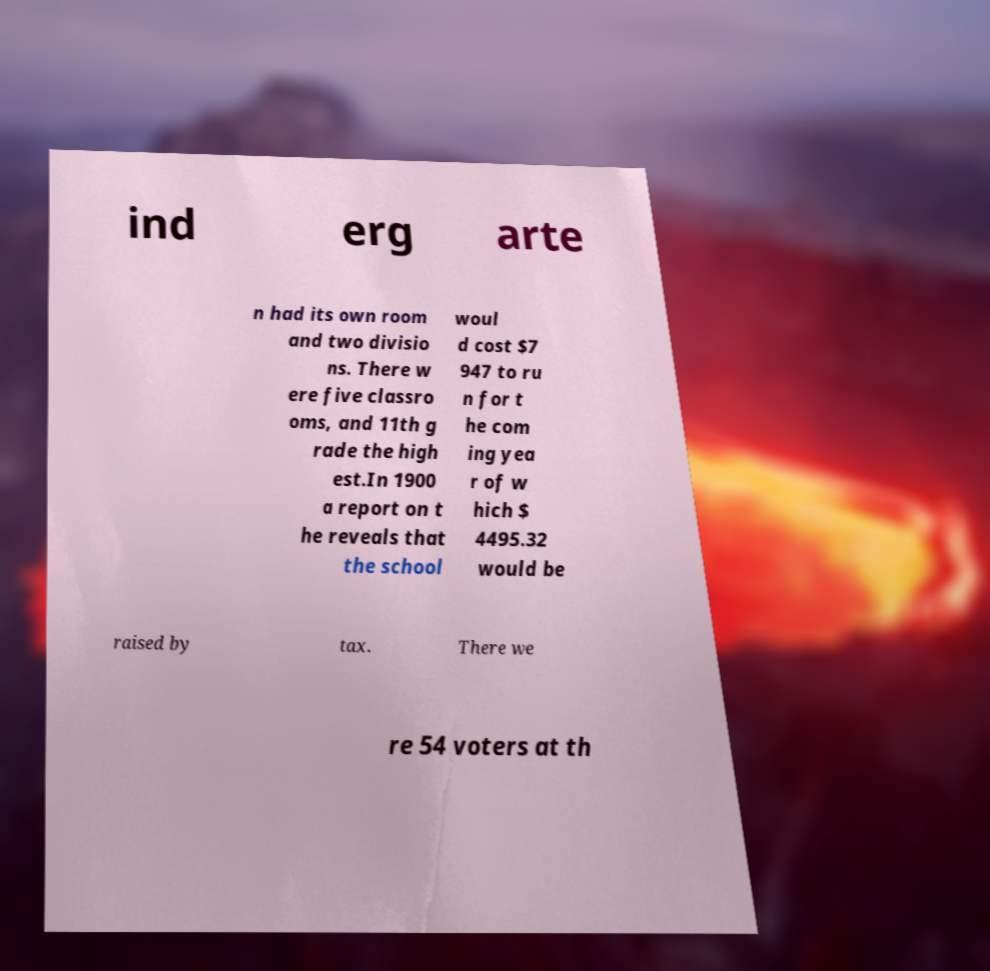Could you assist in decoding the text presented in this image and type it out clearly? ind erg arte n had its own room and two divisio ns. There w ere five classro oms, and 11th g rade the high est.In 1900 a report on t he reveals that the school woul d cost $7 947 to ru n for t he com ing yea r of w hich $ 4495.32 would be raised by tax. There we re 54 voters at th 